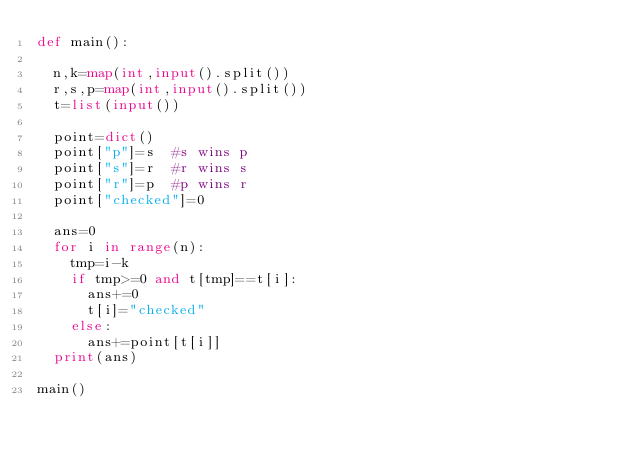<code> <loc_0><loc_0><loc_500><loc_500><_Python_>def main():
 
  n,k=map(int,input().split())
  r,s,p=map(int,input().split())
  t=list(input())
 
  point=dict()
  point["p"]=s  #s wins p
  point["s"]=r  #r wins s
  point["r"]=p  #p wins r
  point["checked"]=0
 
  ans=0
  for i in range(n):
    tmp=i-k
    if tmp>=0 and t[tmp]==t[i]:
      ans+=0
      t[i]="checked"
    else:
      ans+=point[t[i]]
  print(ans)
 
main()</code> 